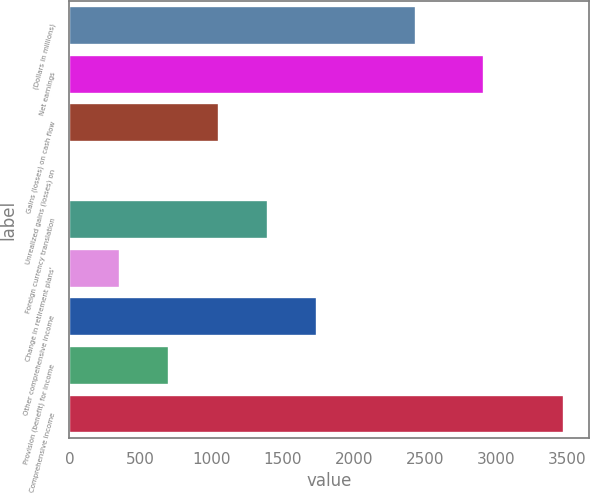Convert chart to OTSL. <chart><loc_0><loc_0><loc_500><loc_500><bar_chart><fcel>(Dollars in millions)<fcel>Net earnings<fcel>Gains (losses) on cash flow<fcel>Unrealized gains (losses) on<fcel>Foreign currency translation<fcel>Change in retirement plans'<fcel>Other comprehensive income<fcel>Provision (benefit) for income<fcel>Comprehensive income<nl><fcel>2438<fcel>2912<fcel>1050<fcel>9<fcel>1397<fcel>356<fcel>1744<fcel>703<fcel>3479<nl></chart> 